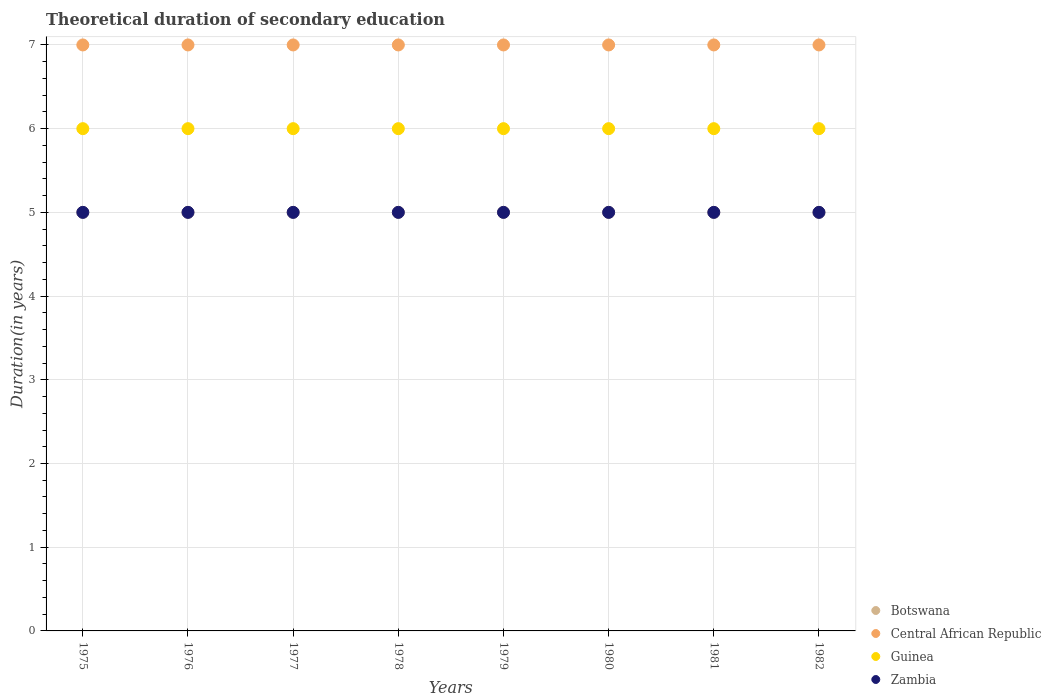What is the total theoretical duration of secondary education in Zambia in 1982?
Give a very brief answer. 5. Across all years, what is the maximum total theoretical duration of secondary education in Botswana?
Offer a very short reply. 5. Across all years, what is the minimum total theoretical duration of secondary education in Central African Republic?
Your answer should be very brief. 7. In which year was the total theoretical duration of secondary education in Botswana maximum?
Your response must be concise. 1975. In which year was the total theoretical duration of secondary education in Central African Republic minimum?
Your answer should be very brief. 1975. What is the total total theoretical duration of secondary education in Zambia in the graph?
Keep it short and to the point. 40. What is the difference between the total theoretical duration of secondary education in Zambia in 1978 and that in 1981?
Your answer should be compact. 0. What is the difference between the total theoretical duration of secondary education in Central African Republic in 1979 and the total theoretical duration of secondary education in Zambia in 1981?
Keep it short and to the point. 2. What is the average total theoretical duration of secondary education in Central African Republic per year?
Provide a short and direct response. 7. In the year 1976, what is the difference between the total theoretical duration of secondary education in Guinea and total theoretical duration of secondary education in Botswana?
Ensure brevity in your answer.  1. What is the ratio of the total theoretical duration of secondary education in Central African Republic in 1979 to that in 1982?
Offer a very short reply. 1. Is the difference between the total theoretical duration of secondary education in Guinea in 1977 and 1978 greater than the difference between the total theoretical duration of secondary education in Botswana in 1977 and 1978?
Your response must be concise. No. In how many years, is the total theoretical duration of secondary education in Guinea greater than the average total theoretical duration of secondary education in Guinea taken over all years?
Give a very brief answer. 0. Is the sum of the total theoretical duration of secondary education in Guinea in 1977 and 1979 greater than the maximum total theoretical duration of secondary education in Botswana across all years?
Your response must be concise. Yes. Is it the case that in every year, the sum of the total theoretical duration of secondary education in Zambia and total theoretical duration of secondary education in Botswana  is greater than the sum of total theoretical duration of secondary education in Guinea and total theoretical duration of secondary education in Central African Republic?
Offer a very short reply. No. Does the total theoretical duration of secondary education in Botswana monotonically increase over the years?
Keep it short and to the point. No. Is the total theoretical duration of secondary education in Guinea strictly less than the total theoretical duration of secondary education in Zambia over the years?
Offer a very short reply. No. How many dotlines are there?
Keep it short and to the point. 4. Does the graph contain any zero values?
Ensure brevity in your answer.  No. How are the legend labels stacked?
Your answer should be very brief. Vertical. What is the title of the graph?
Provide a succinct answer. Theoretical duration of secondary education. What is the label or title of the X-axis?
Your response must be concise. Years. What is the label or title of the Y-axis?
Offer a terse response. Duration(in years). What is the Duration(in years) of Central African Republic in 1975?
Ensure brevity in your answer.  7. What is the Duration(in years) of Guinea in 1975?
Give a very brief answer. 6. What is the Duration(in years) of Botswana in 1976?
Give a very brief answer. 5. What is the Duration(in years) in Central African Republic in 1976?
Provide a short and direct response. 7. What is the Duration(in years) of Guinea in 1976?
Keep it short and to the point. 6. What is the Duration(in years) of Zambia in 1976?
Keep it short and to the point. 5. What is the Duration(in years) of Botswana in 1978?
Provide a short and direct response. 5. What is the Duration(in years) of Guinea in 1978?
Provide a short and direct response. 6. What is the Duration(in years) of Botswana in 1979?
Offer a very short reply. 5. What is the Duration(in years) of Guinea in 1980?
Make the answer very short. 6. What is the Duration(in years) in Central African Republic in 1981?
Offer a terse response. 7. What is the Duration(in years) of Zambia in 1981?
Offer a terse response. 5. What is the Duration(in years) in Central African Republic in 1982?
Your answer should be compact. 7. What is the Duration(in years) of Guinea in 1982?
Your answer should be compact. 6. What is the Duration(in years) of Zambia in 1982?
Give a very brief answer. 5. Across all years, what is the maximum Duration(in years) of Central African Republic?
Give a very brief answer. 7. Across all years, what is the maximum Duration(in years) in Guinea?
Your response must be concise. 6. Across all years, what is the maximum Duration(in years) of Zambia?
Ensure brevity in your answer.  5. Across all years, what is the minimum Duration(in years) in Central African Republic?
Your answer should be compact. 7. Across all years, what is the minimum Duration(in years) in Guinea?
Provide a short and direct response. 6. Across all years, what is the minimum Duration(in years) of Zambia?
Ensure brevity in your answer.  5. What is the total Duration(in years) of Guinea in the graph?
Ensure brevity in your answer.  48. What is the total Duration(in years) of Zambia in the graph?
Keep it short and to the point. 40. What is the difference between the Duration(in years) of Botswana in 1975 and that in 1976?
Ensure brevity in your answer.  0. What is the difference between the Duration(in years) of Central African Republic in 1975 and that in 1976?
Provide a succinct answer. 0. What is the difference between the Duration(in years) of Zambia in 1975 and that in 1976?
Provide a short and direct response. 0. What is the difference between the Duration(in years) of Botswana in 1975 and that in 1977?
Give a very brief answer. 0. What is the difference between the Duration(in years) in Central African Republic in 1975 and that in 1977?
Offer a very short reply. 0. What is the difference between the Duration(in years) of Botswana in 1975 and that in 1978?
Your answer should be compact. 0. What is the difference between the Duration(in years) of Central African Republic in 1975 and that in 1978?
Keep it short and to the point. 0. What is the difference between the Duration(in years) in Guinea in 1975 and that in 1978?
Keep it short and to the point. 0. What is the difference between the Duration(in years) in Zambia in 1975 and that in 1978?
Ensure brevity in your answer.  0. What is the difference between the Duration(in years) in Central African Republic in 1975 and that in 1979?
Your response must be concise. 0. What is the difference between the Duration(in years) in Botswana in 1975 and that in 1980?
Your answer should be compact. 0. What is the difference between the Duration(in years) in Guinea in 1975 and that in 1980?
Your response must be concise. 0. What is the difference between the Duration(in years) in Botswana in 1975 and that in 1981?
Ensure brevity in your answer.  0. What is the difference between the Duration(in years) in Central African Republic in 1975 and that in 1981?
Your answer should be very brief. 0. What is the difference between the Duration(in years) of Guinea in 1975 and that in 1981?
Make the answer very short. 0. What is the difference between the Duration(in years) in Zambia in 1975 and that in 1981?
Your response must be concise. 0. What is the difference between the Duration(in years) of Botswana in 1975 and that in 1982?
Provide a succinct answer. 0. What is the difference between the Duration(in years) in Central African Republic in 1975 and that in 1982?
Your response must be concise. 0. What is the difference between the Duration(in years) of Guinea in 1975 and that in 1982?
Your answer should be very brief. 0. What is the difference between the Duration(in years) of Central African Republic in 1976 and that in 1977?
Offer a very short reply. 0. What is the difference between the Duration(in years) in Guinea in 1976 and that in 1977?
Ensure brevity in your answer.  0. What is the difference between the Duration(in years) of Botswana in 1976 and that in 1978?
Offer a very short reply. 0. What is the difference between the Duration(in years) of Central African Republic in 1976 and that in 1978?
Ensure brevity in your answer.  0. What is the difference between the Duration(in years) in Botswana in 1976 and that in 1979?
Give a very brief answer. 0. What is the difference between the Duration(in years) in Central African Republic in 1976 and that in 1979?
Offer a terse response. 0. What is the difference between the Duration(in years) of Central African Republic in 1976 and that in 1980?
Your response must be concise. 0. What is the difference between the Duration(in years) of Botswana in 1976 and that in 1981?
Offer a terse response. 0. What is the difference between the Duration(in years) in Central African Republic in 1976 and that in 1981?
Make the answer very short. 0. What is the difference between the Duration(in years) of Guinea in 1976 and that in 1981?
Offer a very short reply. 0. What is the difference between the Duration(in years) in Zambia in 1976 and that in 1981?
Offer a terse response. 0. What is the difference between the Duration(in years) of Botswana in 1976 and that in 1982?
Provide a short and direct response. 0. What is the difference between the Duration(in years) of Guinea in 1976 and that in 1982?
Keep it short and to the point. 0. What is the difference between the Duration(in years) in Zambia in 1976 and that in 1982?
Offer a terse response. 0. What is the difference between the Duration(in years) of Botswana in 1977 and that in 1978?
Make the answer very short. 0. What is the difference between the Duration(in years) of Central African Republic in 1977 and that in 1978?
Your answer should be very brief. 0. What is the difference between the Duration(in years) in Guinea in 1977 and that in 1978?
Provide a short and direct response. 0. What is the difference between the Duration(in years) in Zambia in 1977 and that in 1978?
Offer a very short reply. 0. What is the difference between the Duration(in years) in Central African Republic in 1977 and that in 1979?
Offer a terse response. 0. What is the difference between the Duration(in years) of Central African Republic in 1977 and that in 1980?
Give a very brief answer. 0. What is the difference between the Duration(in years) of Guinea in 1977 and that in 1981?
Provide a succinct answer. 0. What is the difference between the Duration(in years) of Botswana in 1977 and that in 1982?
Your answer should be compact. 0. What is the difference between the Duration(in years) in Botswana in 1978 and that in 1979?
Your answer should be compact. 0. What is the difference between the Duration(in years) in Guinea in 1978 and that in 1979?
Your answer should be very brief. 0. What is the difference between the Duration(in years) of Central African Republic in 1978 and that in 1980?
Provide a succinct answer. 0. What is the difference between the Duration(in years) in Guinea in 1978 and that in 1980?
Offer a terse response. 0. What is the difference between the Duration(in years) of Zambia in 1978 and that in 1980?
Give a very brief answer. 0. What is the difference between the Duration(in years) in Zambia in 1978 and that in 1981?
Provide a short and direct response. 0. What is the difference between the Duration(in years) of Botswana in 1978 and that in 1982?
Your answer should be very brief. 0. What is the difference between the Duration(in years) in Guinea in 1978 and that in 1982?
Keep it short and to the point. 0. What is the difference between the Duration(in years) in Central African Republic in 1979 and that in 1980?
Your answer should be very brief. 0. What is the difference between the Duration(in years) of Guinea in 1979 and that in 1980?
Make the answer very short. 0. What is the difference between the Duration(in years) of Zambia in 1979 and that in 1980?
Your answer should be very brief. 0. What is the difference between the Duration(in years) in Botswana in 1979 and that in 1982?
Provide a short and direct response. 0. What is the difference between the Duration(in years) in Guinea in 1979 and that in 1982?
Your answer should be compact. 0. What is the difference between the Duration(in years) in Zambia in 1979 and that in 1982?
Offer a terse response. 0. What is the difference between the Duration(in years) in Botswana in 1980 and that in 1981?
Your answer should be very brief. 0. What is the difference between the Duration(in years) in Central African Republic in 1980 and that in 1981?
Your answer should be very brief. 0. What is the difference between the Duration(in years) of Central African Republic in 1980 and that in 1982?
Offer a very short reply. 0. What is the difference between the Duration(in years) of Zambia in 1980 and that in 1982?
Give a very brief answer. 0. What is the difference between the Duration(in years) in Guinea in 1981 and that in 1982?
Your answer should be very brief. 0. What is the difference between the Duration(in years) in Zambia in 1981 and that in 1982?
Your answer should be compact. 0. What is the difference between the Duration(in years) of Botswana in 1975 and the Duration(in years) of Central African Republic in 1976?
Give a very brief answer. -2. What is the difference between the Duration(in years) of Botswana in 1975 and the Duration(in years) of Guinea in 1976?
Your answer should be very brief. -1. What is the difference between the Duration(in years) of Botswana in 1975 and the Duration(in years) of Zambia in 1976?
Offer a very short reply. 0. What is the difference between the Duration(in years) in Central African Republic in 1975 and the Duration(in years) in Guinea in 1976?
Make the answer very short. 1. What is the difference between the Duration(in years) of Central African Republic in 1975 and the Duration(in years) of Zambia in 1976?
Provide a short and direct response. 2. What is the difference between the Duration(in years) of Guinea in 1975 and the Duration(in years) of Zambia in 1976?
Make the answer very short. 1. What is the difference between the Duration(in years) in Central African Republic in 1975 and the Duration(in years) in Guinea in 1977?
Keep it short and to the point. 1. What is the difference between the Duration(in years) of Botswana in 1975 and the Duration(in years) of Guinea in 1978?
Provide a short and direct response. -1. What is the difference between the Duration(in years) of Central African Republic in 1975 and the Duration(in years) of Zambia in 1978?
Ensure brevity in your answer.  2. What is the difference between the Duration(in years) of Botswana in 1975 and the Duration(in years) of Central African Republic in 1979?
Provide a short and direct response. -2. What is the difference between the Duration(in years) in Botswana in 1975 and the Duration(in years) in Central African Republic in 1980?
Make the answer very short. -2. What is the difference between the Duration(in years) in Botswana in 1975 and the Duration(in years) in Guinea in 1980?
Provide a succinct answer. -1. What is the difference between the Duration(in years) in Central African Republic in 1975 and the Duration(in years) in Guinea in 1980?
Keep it short and to the point. 1. What is the difference between the Duration(in years) of Central African Republic in 1975 and the Duration(in years) of Zambia in 1980?
Your answer should be very brief. 2. What is the difference between the Duration(in years) of Guinea in 1975 and the Duration(in years) of Zambia in 1980?
Provide a short and direct response. 1. What is the difference between the Duration(in years) in Botswana in 1975 and the Duration(in years) in Central African Republic in 1981?
Your answer should be compact. -2. What is the difference between the Duration(in years) of Central African Republic in 1975 and the Duration(in years) of Guinea in 1981?
Make the answer very short. 1. What is the difference between the Duration(in years) of Central African Republic in 1975 and the Duration(in years) of Zambia in 1981?
Your answer should be very brief. 2. What is the difference between the Duration(in years) of Guinea in 1975 and the Duration(in years) of Zambia in 1981?
Make the answer very short. 1. What is the difference between the Duration(in years) of Botswana in 1975 and the Duration(in years) of Central African Republic in 1982?
Provide a succinct answer. -2. What is the difference between the Duration(in years) of Botswana in 1975 and the Duration(in years) of Zambia in 1982?
Give a very brief answer. 0. What is the difference between the Duration(in years) in Central African Republic in 1975 and the Duration(in years) in Guinea in 1982?
Your answer should be very brief. 1. What is the difference between the Duration(in years) of Guinea in 1975 and the Duration(in years) of Zambia in 1982?
Keep it short and to the point. 1. What is the difference between the Duration(in years) in Central African Republic in 1976 and the Duration(in years) in Guinea in 1977?
Your answer should be compact. 1. What is the difference between the Duration(in years) of Guinea in 1976 and the Duration(in years) of Zambia in 1977?
Offer a very short reply. 1. What is the difference between the Duration(in years) of Botswana in 1976 and the Duration(in years) of Guinea in 1978?
Provide a succinct answer. -1. What is the difference between the Duration(in years) in Botswana in 1976 and the Duration(in years) in Zambia in 1978?
Keep it short and to the point. 0. What is the difference between the Duration(in years) of Botswana in 1976 and the Duration(in years) of Central African Republic in 1979?
Your response must be concise. -2. What is the difference between the Duration(in years) of Botswana in 1976 and the Duration(in years) of Zambia in 1979?
Offer a terse response. 0. What is the difference between the Duration(in years) in Central African Republic in 1976 and the Duration(in years) in Guinea in 1979?
Provide a short and direct response. 1. What is the difference between the Duration(in years) in Central African Republic in 1976 and the Duration(in years) in Zambia in 1979?
Give a very brief answer. 2. What is the difference between the Duration(in years) in Botswana in 1976 and the Duration(in years) in Zambia in 1980?
Give a very brief answer. 0. What is the difference between the Duration(in years) of Central African Republic in 1976 and the Duration(in years) of Zambia in 1980?
Provide a short and direct response. 2. What is the difference between the Duration(in years) in Botswana in 1976 and the Duration(in years) in Guinea in 1981?
Provide a succinct answer. -1. What is the difference between the Duration(in years) in Guinea in 1976 and the Duration(in years) in Zambia in 1981?
Keep it short and to the point. 1. What is the difference between the Duration(in years) of Botswana in 1977 and the Duration(in years) of Central African Republic in 1978?
Keep it short and to the point. -2. What is the difference between the Duration(in years) of Central African Republic in 1977 and the Duration(in years) of Guinea in 1978?
Provide a succinct answer. 1. What is the difference between the Duration(in years) in Guinea in 1977 and the Duration(in years) in Zambia in 1978?
Your response must be concise. 1. What is the difference between the Duration(in years) in Botswana in 1977 and the Duration(in years) in Central African Republic in 1979?
Your response must be concise. -2. What is the difference between the Duration(in years) of Botswana in 1977 and the Duration(in years) of Guinea in 1979?
Make the answer very short. -1. What is the difference between the Duration(in years) in Botswana in 1977 and the Duration(in years) in Zambia in 1979?
Provide a succinct answer. 0. What is the difference between the Duration(in years) in Central African Republic in 1977 and the Duration(in years) in Guinea in 1979?
Make the answer very short. 1. What is the difference between the Duration(in years) of Central African Republic in 1977 and the Duration(in years) of Zambia in 1979?
Keep it short and to the point. 2. What is the difference between the Duration(in years) of Guinea in 1977 and the Duration(in years) of Zambia in 1979?
Your response must be concise. 1. What is the difference between the Duration(in years) of Central African Republic in 1977 and the Duration(in years) of Guinea in 1980?
Provide a short and direct response. 1. What is the difference between the Duration(in years) of Central African Republic in 1977 and the Duration(in years) of Zambia in 1980?
Provide a succinct answer. 2. What is the difference between the Duration(in years) of Botswana in 1977 and the Duration(in years) of Guinea in 1981?
Give a very brief answer. -1. What is the difference between the Duration(in years) of Botswana in 1977 and the Duration(in years) of Zambia in 1981?
Provide a succinct answer. 0. What is the difference between the Duration(in years) in Central African Republic in 1977 and the Duration(in years) in Zambia in 1981?
Offer a terse response. 2. What is the difference between the Duration(in years) in Guinea in 1977 and the Duration(in years) in Zambia in 1981?
Give a very brief answer. 1. What is the difference between the Duration(in years) in Botswana in 1977 and the Duration(in years) in Central African Republic in 1982?
Provide a succinct answer. -2. What is the difference between the Duration(in years) in Botswana in 1977 and the Duration(in years) in Guinea in 1982?
Your response must be concise. -1. What is the difference between the Duration(in years) of Botswana in 1977 and the Duration(in years) of Zambia in 1982?
Provide a short and direct response. 0. What is the difference between the Duration(in years) in Central African Republic in 1977 and the Duration(in years) in Guinea in 1982?
Provide a succinct answer. 1. What is the difference between the Duration(in years) of Guinea in 1977 and the Duration(in years) of Zambia in 1982?
Ensure brevity in your answer.  1. What is the difference between the Duration(in years) of Botswana in 1978 and the Duration(in years) of Central African Republic in 1979?
Your response must be concise. -2. What is the difference between the Duration(in years) in Central African Republic in 1978 and the Duration(in years) in Guinea in 1979?
Make the answer very short. 1. What is the difference between the Duration(in years) of Guinea in 1978 and the Duration(in years) of Zambia in 1979?
Offer a very short reply. 1. What is the difference between the Duration(in years) of Botswana in 1978 and the Duration(in years) of Central African Republic in 1980?
Ensure brevity in your answer.  -2. What is the difference between the Duration(in years) of Central African Republic in 1978 and the Duration(in years) of Zambia in 1980?
Provide a succinct answer. 2. What is the difference between the Duration(in years) of Guinea in 1978 and the Duration(in years) of Zambia in 1980?
Your answer should be very brief. 1. What is the difference between the Duration(in years) in Botswana in 1978 and the Duration(in years) in Guinea in 1981?
Keep it short and to the point. -1. What is the difference between the Duration(in years) of Central African Republic in 1978 and the Duration(in years) of Guinea in 1981?
Your answer should be very brief. 1. What is the difference between the Duration(in years) in Guinea in 1978 and the Duration(in years) in Zambia in 1981?
Your answer should be compact. 1. What is the difference between the Duration(in years) in Botswana in 1978 and the Duration(in years) in Guinea in 1982?
Provide a short and direct response. -1. What is the difference between the Duration(in years) in Guinea in 1978 and the Duration(in years) in Zambia in 1982?
Your response must be concise. 1. What is the difference between the Duration(in years) in Botswana in 1979 and the Duration(in years) in Central African Republic in 1980?
Your answer should be very brief. -2. What is the difference between the Duration(in years) of Botswana in 1979 and the Duration(in years) of Zambia in 1980?
Your response must be concise. 0. What is the difference between the Duration(in years) of Central African Republic in 1979 and the Duration(in years) of Zambia in 1980?
Offer a very short reply. 2. What is the difference between the Duration(in years) of Central African Republic in 1979 and the Duration(in years) of Zambia in 1981?
Your answer should be very brief. 2. What is the difference between the Duration(in years) in Botswana in 1979 and the Duration(in years) in Guinea in 1982?
Ensure brevity in your answer.  -1. What is the difference between the Duration(in years) in Botswana in 1979 and the Duration(in years) in Zambia in 1982?
Keep it short and to the point. 0. What is the difference between the Duration(in years) of Central African Republic in 1979 and the Duration(in years) of Guinea in 1982?
Provide a short and direct response. 1. What is the difference between the Duration(in years) of Botswana in 1980 and the Duration(in years) of Central African Republic in 1981?
Your answer should be compact. -2. What is the difference between the Duration(in years) in Central African Republic in 1980 and the Duration(in years) in Guinea in 1981?
Offer a terse response. 1. What is the difference between the Duration(in years) in Guinea in 1980 and the Duration(in years) in Zambia in 1981?
Your response must be concise. 1. What is the difference between the Duration(in years) in Central African Republic in 1980 and the Duration(in years) in Guinea in 1982?
Provide a succinct answer. 1. What is the difference between the Duration(in years) in Central African Republic in 1980 and the Duration(in years) in Zambia in 1982?
Ensure brevity in your answer.  2. What is the difference between the Duration(in years) of Guinea in 1980 and the Duration(in years) of Zambia in 1982?
Give a very brief answer. 1. What is the difference between the Duration(in years) of Botswana in 1981 and the Duration(in years) of Central African Republic in 1982?
Provide a succinct answer. -2. What is the difference between the Duration(in years) in Botswana in 1981 and the Duration(in years) in Zambia in 1982?
Keep it short and to the point. 0. What is the difference between the Duration(in years) in Central African Republic in 1981 and the Duration(in years) in Guinea in 1982?
Your response must be concise. 1. What is the difference between the Duration(in years) in Central African Republic in 1981 and the Duration(in years) in Zambia in 1982?
Give a very brief answer. 2. What is the average Duration(in years) in Zambia per year?
Your response must be concise. 5. In the year 1975, what is the difference between the Duration(in years) in Botswana and Duration(in years) in Central African Republic?
Your answer should be very brief. -2. In the year 1975, what is the difference between the Duration(in years) in Central African Republic and Duration(in years) in Guinea?
Your answer should be compact. 1. In the year 1976, what is the difference between the Duration(in years) of Botswana and Duration(in years) of Zambia?
Make the answer very short. 0. In the year 1976, what is the difference between the Duration(in years) of Central African Republic and Duration(in years) of Zambia?
Your answer should be very brief. 2. In the year 1977, what is the difference between the Duration(in years) in Botswana and Duration(in years) in Central African Republic?
Offer a very short reply. -2. In the year 1977, what is the difference between the Duration(in years) in Botswana and Duration(in years) in Zambia?
Keep it short and to the point. 0. In the year 1977, what is the difference between the Duration(in years) in Guinea and Duration(in years) in Zambia?
Your response must be concise. 1. In the year 1978, what is the difference between the Duration(in years) of Botswana and Duration(in years) of Central African Republic?
Provide a short and direct response. -2. In the year 1978, what is the difference between the Duration(in years) of Botswana and Duration(in years) of Guinea?
Offer a terse response. -1. In the year 1978, what is the difference between the Duration(in years) of Central African Republic and Duration(in years) of Zambia?
Your response must be concise. 2. In the year 1978, what is the difference between the Duration(in years) in Guinea and Duration(in years) in Zambia?
Ensure brevity in your answer.  1. In the year 1979, what is the difference between the Duration(in years) in Botswana and Duration(in years) in Zambia?
Give a very brief answer. 0. In the year 1980, what is the difference between the Duration(in years) of Botswana and Duration(in years) of Central African Republic?
Your answer should be compact. -2. In the year 1980, what is the difference between the Duration(in years) in Botswana and Duration(in years) in Guinea?
Give a very brief answer. -1. In the year 1980, what is the difference between the Duration(in years) of Botswana and Duration(in years) of Zambia?
Your answer should be very brief. 0. In the year 1980, what is the difference between the Duration(in years) in Central African Republic and Duration(in years) in Guinea?
Offer a terse response. 1. In the year 1980, what is the difference between the Duration(in years) of Central African Republic and Duration(in years) of Zambia?
Your answer should be very brief. 2. In the year 1980, what is the difference between the Duration(in years) of Guinea and Duration(in years) of Zambia?
Your answer should be very brief. 1. In the year 1981, what is the difference between the Duration(in years) in Botswana and Duration(in years) in Guinea?
Offer a very short reply. -1. In the year 1981, what is the difference between the Duration(in years) in Botswana and Duration(in years) in Zambia?
Ensure brevity in your answer.  0. In the year 1981, what is the difference between the Duration(in years) of Central African Republic and Duration(in years) of Zambia?
Ensure brevity in your answer.  2. In the year 1982, what is the difference between the Duration(in years) in Botswana and Duration(in years) in Central African Republic?
Give a very brief answer. -2. In the year 1982, what is the difference between the Duration(in years) in Botswana and Duration(in years) in Guinea?
Make the answer very short. -1. In the year 1982, what is the difference between the Duration(in years) in Botswana and Duration(in years) in Zambia?
Ensure brevity in your answer.  0. In the year 1982, what is the difference between the Duration(in years) in Central African Republic and Duration(in years) in Guinea?
Keep it short and to the point. 1. What is the ratio of the Duration(in years) of Botswana in 1975 to that in 1976?
Provide a succinct answer. 1. What is the ratio of the Duration(in years) of Zambia in 1975 to that in 1976?
Offer a terse response. 1. What is the ratio of the Duration(in years) of Botswana in 1975 to that in 1977?
Ensure brevity in your answer.  1. What is the ratio of the Duration(in years) in Guinea in 1975 to that in 1977?
Give a very brief answer. 1. What is the ratio of the Duration(in years) of Zambia in 1975 to that in 1977?
Your answer should be very brief. 1. What is the ratio of the Duration(in years) in Guinea in 1975 to that in 1978?
Your response must be concise. 1. What is the ratio of the Duration(in years) in Botswana in 1975 to that in 1979?
Offer a terse response. 1. What is the ratio of the Duration(in years) in Botswana in 1975 to that in 1980?
Ensure brevity in your answer.  1. What is the ratio of the Duration(in years) of Central African Republic in 1975 to that in 1980?
Your response must be concise. 1. What is the ratio of the Duration(in years) of Zambia in 1975 to that in 1980?
Your answer should be compact. 1. What is the ratio of the Duration(in years) in Zambia in 1975 to that in 1981?
Your answer should be very brief. 1. What is the ratio of the Duration(in years) in Central African Republic in 1975 to that in 1982?
Your answer should be compact. 1. What is the ratio of the Duration(in years) of Guinea in 1975 to that in 1982?
Make the answer very short. 1. What is the ratio of the Duration(in years) of Zambia in 1975 to that in 1982?
Offer a very short reply. 1. What is the ratio of the Duration(in years) of Botswana in 1976 to that in 1977?
Offer a very short reply. 1. What is the ratio of the Duration(in years) in Guinea in 1976 to that in 1977?
Offer a terse response. 1. What is the ratio of the Duration(in years) of Central African Republic in 1976 to that in 1978?
Make the answer very short. 1. What is the ratio of the Duration(in years) in Central African Republic in 1976 to that in 1979?
Keep it short and to the point. 1. What is the ratio of the Duration(in years) in Zambia in 1976 to that in 1979?
Offer a terse response. 1. What is the ratio of the Duration(in years) in Central African Republic in 1976 to that in 1980?
Make the answer very short. 1. What is the ratio of the Duration(in years) in Botswana in 1976 to that in 1981?
Your answer should be very brief. 1. What is the ratio of the Duration(in years) in Guinea in 1976 to that in 1981?
Give a very brief answer. 1. What is the ratio of the Duration(in years) of Zambia in 1976 to that in 1981?
Offer a very short reply. 1. What is the ratio of the Duration(in years) in Central African Republic in 1976 to that in 1982?
Provide a succinct answer. 1. What is the ratio of the Duration(in years) of Zambia in 1976 to that in 1982?
Give a very brief answer. 1. What is the ratio of the Duration(in years) in Guinea in 1977 to that in 1978?
Your response must be concise. 1. What is the ratio of the Duration(in years) in Guinea in 1977 to that in 1979?
Your response must be concise. 1. What is the ratio of the Duration(in years) in Botswana in 1977 to that in 1980?
Your answer should be compact. 1. What is the ratio of the Duration(in years) in Guinea in 1977 to that in 1980?
Give a very brief answer. 1. What is the ratio of the Duration(in years) in Zambia in 1977 to that in 1980?
Your response must be concise. 1. What is the ratio of the Duration(in years) in Central African Republic in 1977 to that in 1981?
Ensure brevity in your answer.  1. What is the ratio of the Duration(in years) of Central African Republic in 1977 to that in 1982?
Ensure brevity in your answer.  1. What is the ratio of the Duration(in years) in Zambia in 1977 to that in 1982?
Give a very brief answer. 1. What is the ratio of the Duration(in years) in Guinea in 1978 to that in 1979?
Offer a terse response. 1. What is the ratio of the Duration(in years) in Zambia in 1978 to that in 1979?
Offer a very short reply. 1. What is the ratio of the Duration(in years) of Zambia in 1978 to that in 1981?
Offer a very short reply. 1. What is the ratio of the Duration(in years) of Botswana in 1978 to that in 1982?
Offer a terse response. 1. What is the ratio of the Duration(in years) in Guinea in 1978 to that in 1982?
Ensure brevity in your answer.  1. What is the ratio of the Duration(in years) in Zambia in 1979 to that in 1980?
Your answer should be very brief. 1. What is the ratio of the Duration(in years) in Zambia in 1979 to that in 1981?
Give a very brief answer. 1. What is the ratio of the Duration(in years) in Botswana in 1979 to that in 1982?
Offer a very short reply. 1. What is the ratio of the Duration(in years) of Central African Republic in 1979 to that in 1982?
Keep it short and to the point. 1. What is the ratio of the Duration(in years) in Zambia in 1979 to that in 1982?
Make the answer very short. 1. What is the ratio of the Duration(in years) of Central African Republic in 1980 to that in 1981?
Your response must be concise. 1. What is the ratio of the Duration(in years) of Zambia in 1980 to that in 1982?
Your response must be concise. 1. What is the ratio of the Duration(in years) of Guinea in 1981 to that in 1982?
Give a very brief answer. 1. What is the ratio of the Duration(in years) of Zambia in 1981 to that in 1982?
Provide a short and direct response. 1. What is the difference between the highest and the second highest Duration(in years) in Botswana?
Ensure brevity in your answer.  0. What is the difference between the highest and the second highest Duration(in years) of Central African Republic?
Keep it short and to the point. 0. What is the difference between the highest and the second highest Duration(in years) in Guinea?
Make the answer very short. 0. What is the difference between the highest and the second highest Duration(in years) in Zambia?
Your answer should be very brief. 0. What is the difference between the highest and the lowest Duration(in years) in Zambia?
Give a very brief answer. 0. 